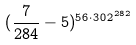Convert formula to latex. <formula><loc_0><loc_0><loc_500><loc_500>( \frac { 7 } { 2 8 4 } - 5 ) ^ { 5 6 \cdot 3 0 2 ^ { 2 8 2 } }</formula> 